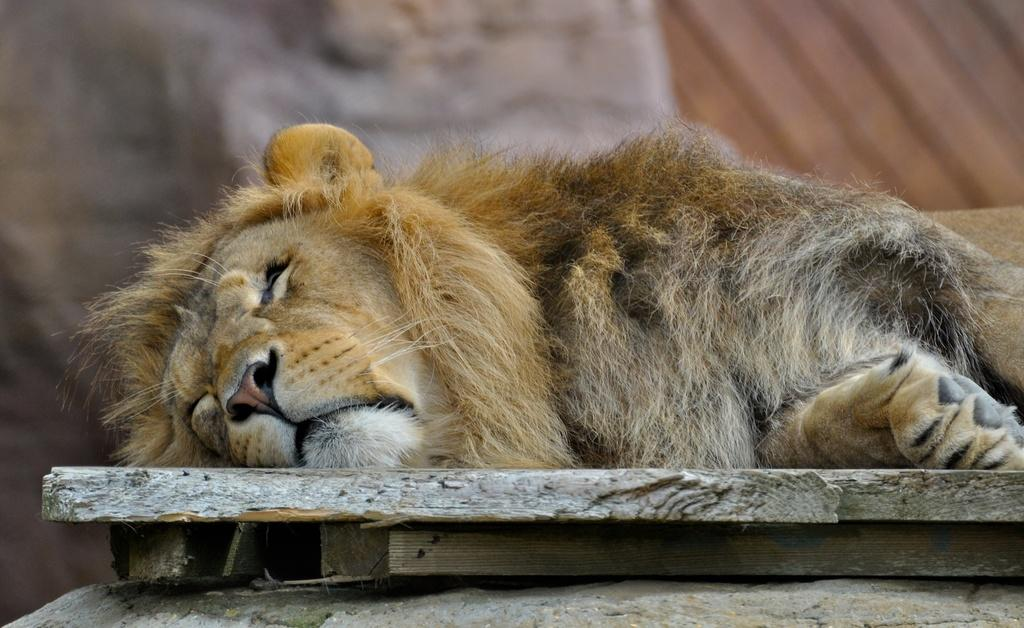What animal is the main subject of the image? There is a lion in the image. What is the lion lying on? The lion is lying on a wooden object. Can you describe the background of the image? The background of the image appears blurry. What type of stone can be seen being thrown during the protest in the image? There is no protest or stone present in the image; it features a lion lying on a wooden object with a blurry background. What part of the brain is visible in the image? There is no brain present in the image; it features a lion lying on a wooden object with a blurry background. 